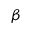Convert formula to latex. <formula><loc_0><loc_0><loc_500><loc_500>\beta</formula> 